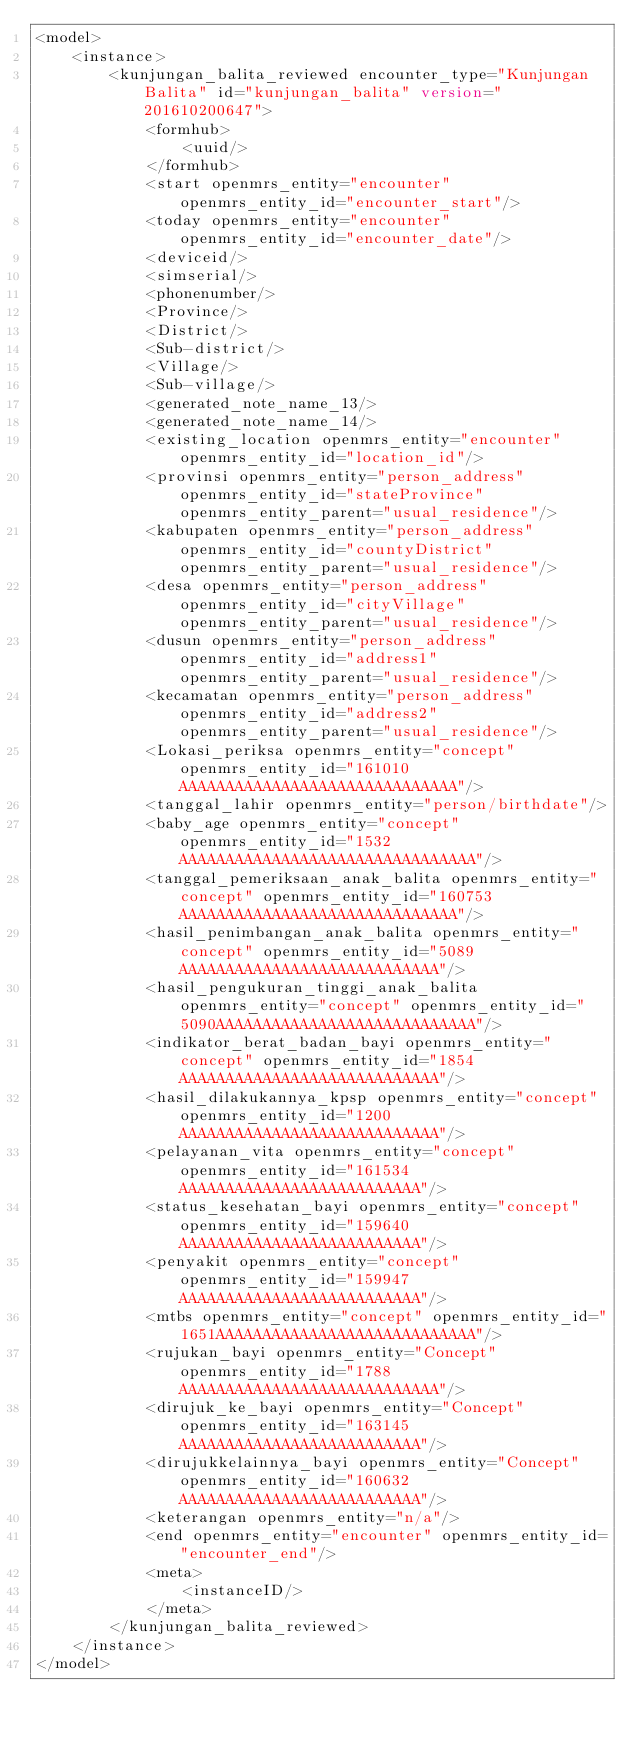Convert code to text. <code><loc_0><loc_0><loc_500><loc_500><_XML_><model>
    <instance>
        <kunjungan_balita_reviewed encounter_type="Kunjungan Balita" id="kunjungan_balita" version="201610200647">
            <formhub>
                <uuid/>
            </formhub>
            <start openmrs_entity="encounter" openmrs_entity_id="encounter_start"/>
            <today openmrs_entity="encounter" openmrs_entity_id="encounter_date"/>
            <deviceid/>
            <simserial/>
            <phonenumber/>
            <Province/>
            <District/>
            <Sub-district/>
            <Village/>
            <Sub-village/>
            <generated_note_name_13/>
            <generated_note_name_14/>
            <existing_location openmrs_entity="encounter" openmrs_entity_id="location_id"/>
            <provinsi openmrs_entity="person_address" openmrs_entity_id="stateProvince" openmrs_entity_parent="usual_residence"/>
            <kabupaten openmrs_entity="person_address" openmrs_entity_id="countyDistrict" openmrs_entity_parent="usual_residence"/>
            <desa openmrs_entity="person_address" openmrs_entity_id="cityVillage" openmrs_entity_parent="usual_residence"/>
            <dusun openmrs_entity="person_address" openmrs_entity_id="address1" openmrs_entity_parent="usual_residence"/>
            <kecamatan openmrs_entity="person_address" openmrs_entity_id="address2" openmrs_entity_parent="usual_residence"/>
            <Lokasi_periksa openmrs_entity="concept" openmrs_entity_id="161010AAAAAAAAAAAAAAAAAAAAAAAAAAAAAA"/>
            <tanggal_lahir openmrs_entity="person/birthdate"/>
            <baby_age openmrs_entity="concept" openmrs_entity_id="1532AAAAAAAAAAAAAAAAAAAAAAAAAAAAAAAA"/>
            <tanggal_pemeriksaan_anak_balita openmrs_entity="concept" openmrs_entity_id="160753AAAAAAAAAAAAAAAAAAAAAAAAAAAAAA"/>
            <hasil_penimbangan_anak_balita openmrs_entity="concept" openmrs_entity_id="5089AAAAAAAAAAAAAAAAAAAAAAAAAAAA"/>
            <hasil_pengukuran_tinggi_anak_balita openmrs_entity="concept" openmrs_entity_id="5090AAAAAAAAAAAAAAAAAAAAAAAAAAAA"/>
            <indikator_berat_badan_bayi openmrs_entity="concept" openmrs_entity_id="1854AAAAAAAAAAAAAAAAAAAAAAAAAAAA"/>
            <hasil_dilakukannya_kpsp openmrs_entity="concept" openmrs_entity_id="1200AAAAAAAAAAAAAAAAAAAAAAAAAAAA"/>
            <pelayanan_vita openmrs_entity="concept" openmrs_entity_id="161534AAAAAAAAAAAAAAAAAAAAAAAAAA"/>
            <status_kesehatan_bayi openmrs_entity="concept" openmrs_entity_id="159640AAAAAAAAAAAAAAAAAAAAAAAAAA"/>
            <penyakit openmrs_entity="concept" openmrs_entity_id="159947AAAAAAAAAAAAAAAAAAAAAAAAAA"/>
            <mtbs openmrs_entity="concept" openmrs_entity_id="1651AAAAAAAAAAAAAAAAAAAAAAAAAAAA"/>
            <rujukan_bayi openmrs_entity="Concept" openmrs_entity_id="1788AAAAAAAAAAAAAAAAAAAAAAAAAAAA"/>
            <dirujuk_ke_bayi openmrs_entity="Concept" openmrs_entity_id="163145AAAAAAAAAAAAAAAAAAAAAAAAAA"/>
            <dirujukkelainnya_bayi openmrs_entity="Concept" openmrs_entity_id="160632AAAAAAAAAAAAAAAAAAAAAAAAAA"/>
            <keterangan openmrs_entity="n/a"/>
            <end openmrs_entity="encounter" openmrs_entity_id="encounter_end"/>
            <meta>
                <instanceID/>
            </meta>
        </kunjungan_balita_reviewed>
    </instance>
</model></code> 